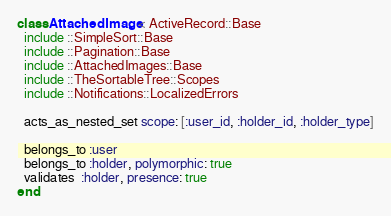Convert code to text. <code><loc_0><loc_0><loc_500><loc_500><_Ruby_>class AttachedImage < ActiveRecord::Base
  include ::SimpleSort::Base
  include ::Pagination::Base
  include ::AttachedImages::Base
  include ::TheSortableTree::Scopes
  include ::Notifications::LocalizedErrors

  acts_as_nested_set scope: [:user_id, :holder_id, :holder_type]

  belongs_to :user
  belongs_to :holder, polymorphic: true
  validates  :holder, presence: true
end</code> 